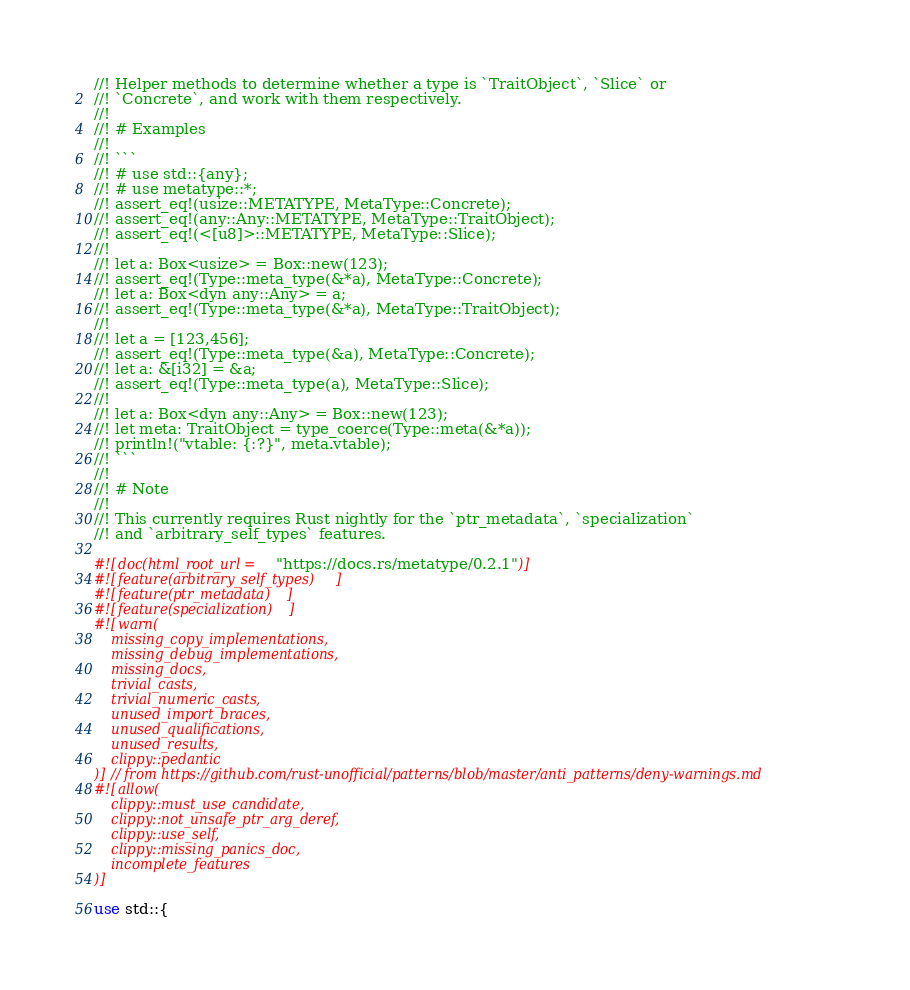Convert code to text. <code><loc_0><loc_0><loc_500><loc_500><_Rust_>//! Helper methods to determine whether a type is `TraitObject`, `Slice` or
//! `Concrete`, and work with them respectively.
//!
//! # Examples
//!
//! ```
//! # use std::{any};
//! # use metatype::*;
//! assert_eq!(usize::METATYPE, MetaType::Concrete);
//! assert_eq!(any::Any::METATYPE, MetaType::TraitObject);
//! assert_eq!(<[u8]>::METATYPE, MetaType::Slice);
//!
//! let a: Box<usize> = Box::new(123);
//! assert_eq!(Type::meta_type(&*a), MetaType::Concrete);
//! let a: Box<dyn any::Any> = a;
//! assert_eq!(Type::meta_type(&*a), MetaType::TraitObject);
//!
//! let a = [123,456];
//! assert_eq!(Type::meta_type(&a), MetaType::Concrete);
//! let a: &[i32] = &a;
//! assert_eq!(Type::meta_type(a), MetaType::Slice);
//!
//! let a: Box<dyn any::Any> = Box::new(123);
//! let meta: TraitObject = type_coerce(Type::meta(&*a));
//! println!("vtable: {:?}", meta.vtable);
//! ```
//!
//! # Note
//!
//! This currently requires Rust nightly for the `ptr_metadata`, `specialization`
//! and `arbitrary_self_types` features.

#![doc(html_root_url = "https://docs.rs/metatype/0.2.1")]
#![feature(arbitrary_self_types)]
#![feature(ptr_metadata)]
#![feature(specialization)]
#![warn(
	missing_copy_implementations,
	missing_debug_implementations,
	missing_docs,
	trivial_casts,
	trivial_numeric_casts,
	unused_import_braces,
	unused_qualifications,
	unused_results,
	clippy::pedantic
)] // from https://github.com/rust-unofficial/patterns/blob/master/anti_patterns/deny-warnings.md
#![allow(
	clippy::must_use_candidate,
	clippy::not_unsafe_ptr_arg_deref,
	clippy::use_self,
	clippy::missing_panics_doc,
	incomplete_features
)]

use std::{</code> 